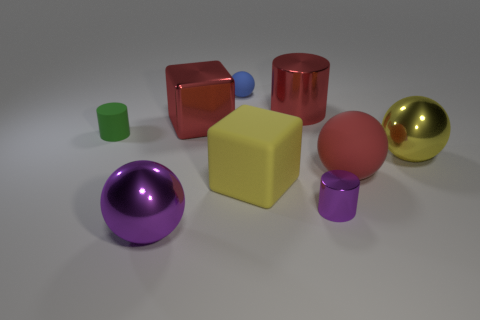There is a shiny sphere on the right side of the large metal ball to the left of the yellow block; what color is it?
Provide a short and direct response. Yellow. What is the material of the small cylinder to the left of the tiny cylinder that is to the right of the small cylinder that is on the left side of the large purple metal ball?
Your answer should be compact. Rubber. How many red matte things have the same size as the blue matte ball?
Keep it short and to the point. 0. There is a tiny object that is to the right of the tiny green matte cylinder and behind the purple cylinder; what material is it made of?
Ensure brevity in your answer.  Rubber. What number of large red matte objects are behind the green cylinder?
Offer a very short reply. 0. Do the big yellow metallic object and the large shiny thing that is in front of the large yellow cube have the same shape?
Offer a terse response. Yes. Is there another purple object of the same shape as the tiny metal thing?
Your answer should be compact. No. What shape is the purple metallic object that is behind the object in front of the purple metallic cylinder?
Provide a succinct answer. Cylinder. There is a purple thing that is behind the large purple sphere; what is its shape?
Make the answer very short. Cylinder. There is a cylinder that is to the left of the tiny sphere; is its color the same as the ball behind the large red cylinder?
Provide a succinct answer. No. 